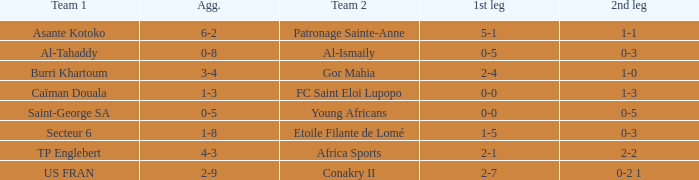Which team lost 0-3 and 0-5? Al-Tahaddy. 